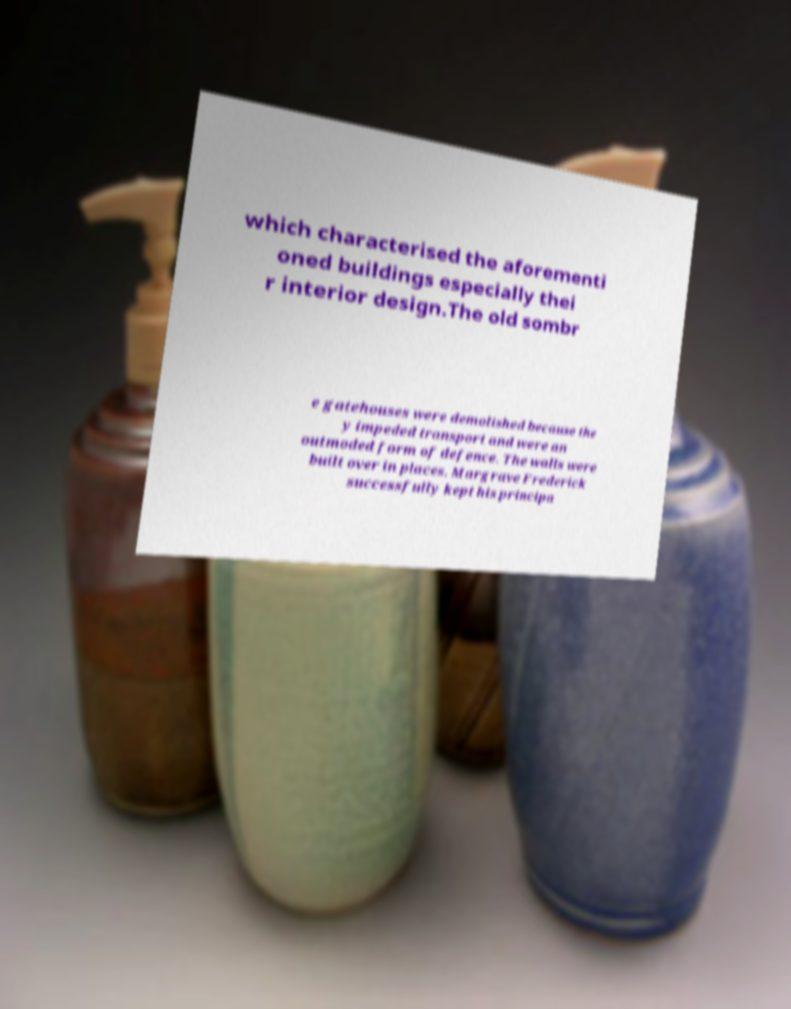Can you read and provide the text displayed in the image?This photo seems to have some interesting text. Can you extract and type it out for me? which characterised the aforementi oned buildings especially thei r interior design.The old sombr e gatehouses were demolished because the y impeded transport and were an outmoded form of defence. The walls were built over in places. Margrave Frederick successfully kept his principa 